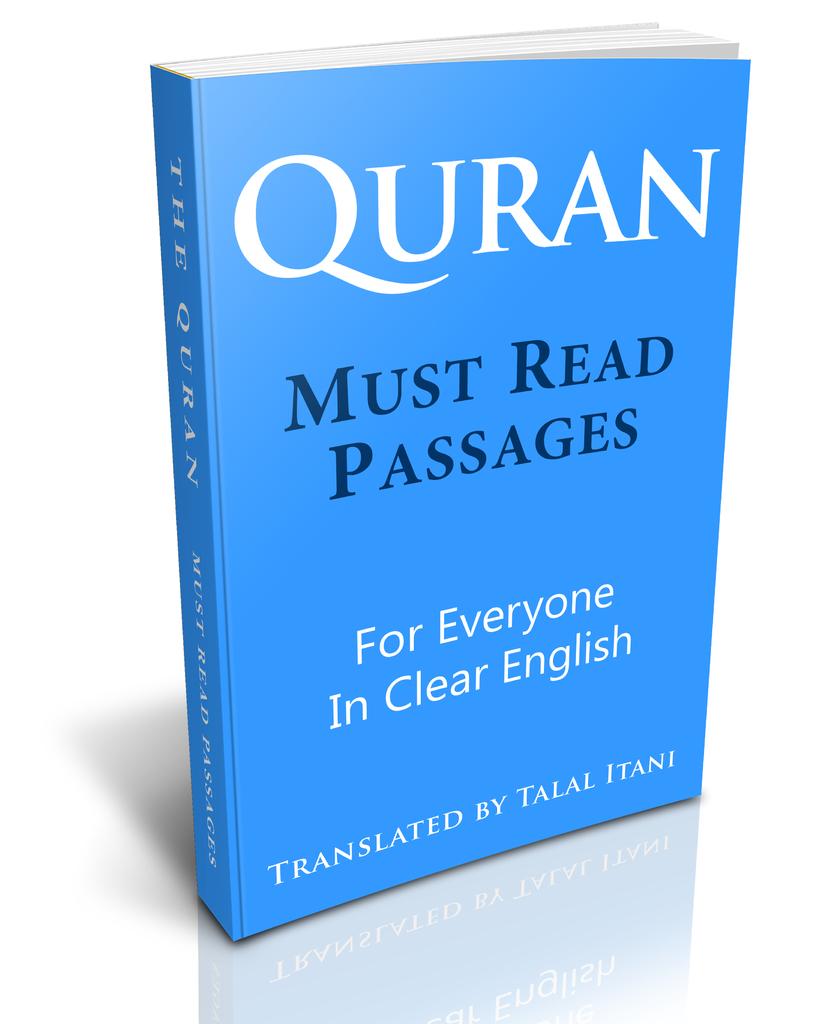Are these "must read"?
Provide a short and direct response. Yes. 